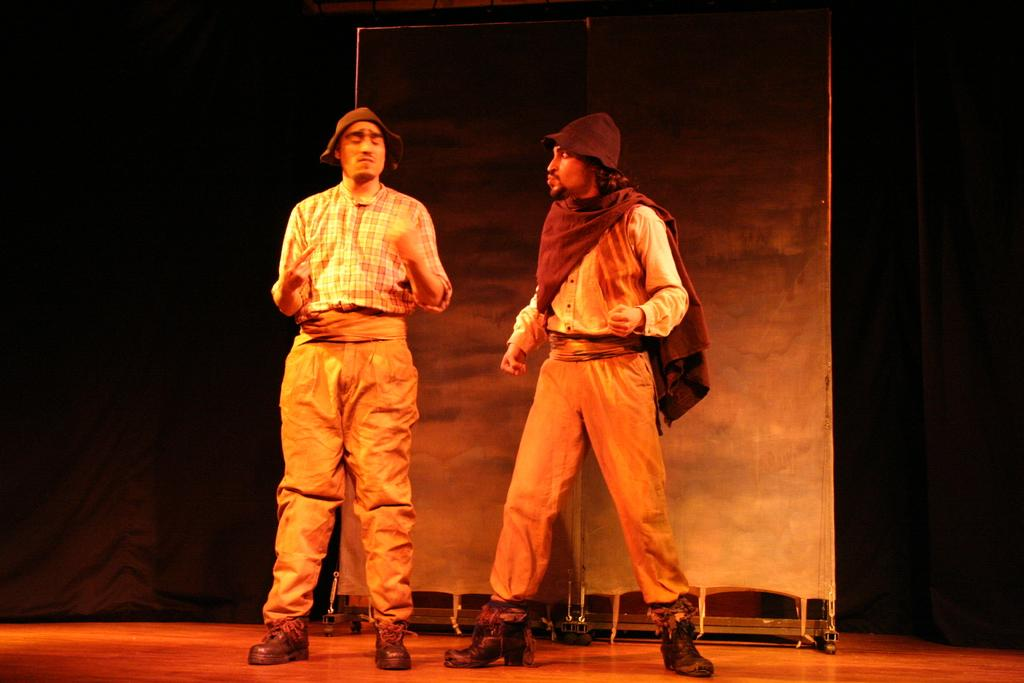How many people are in the image? There are two men in the image. What are the men doing in the image? The men are standing. What are the men wearing on their heads? The men are wearing hats. What type of steel is being used by the fireman in the image? There is no fireman or steel present in the image. What scientific experiment is being conducted by the men in the image? There is no scientific experiment being conducted in the image; the men are simply standing and wearing hats. 